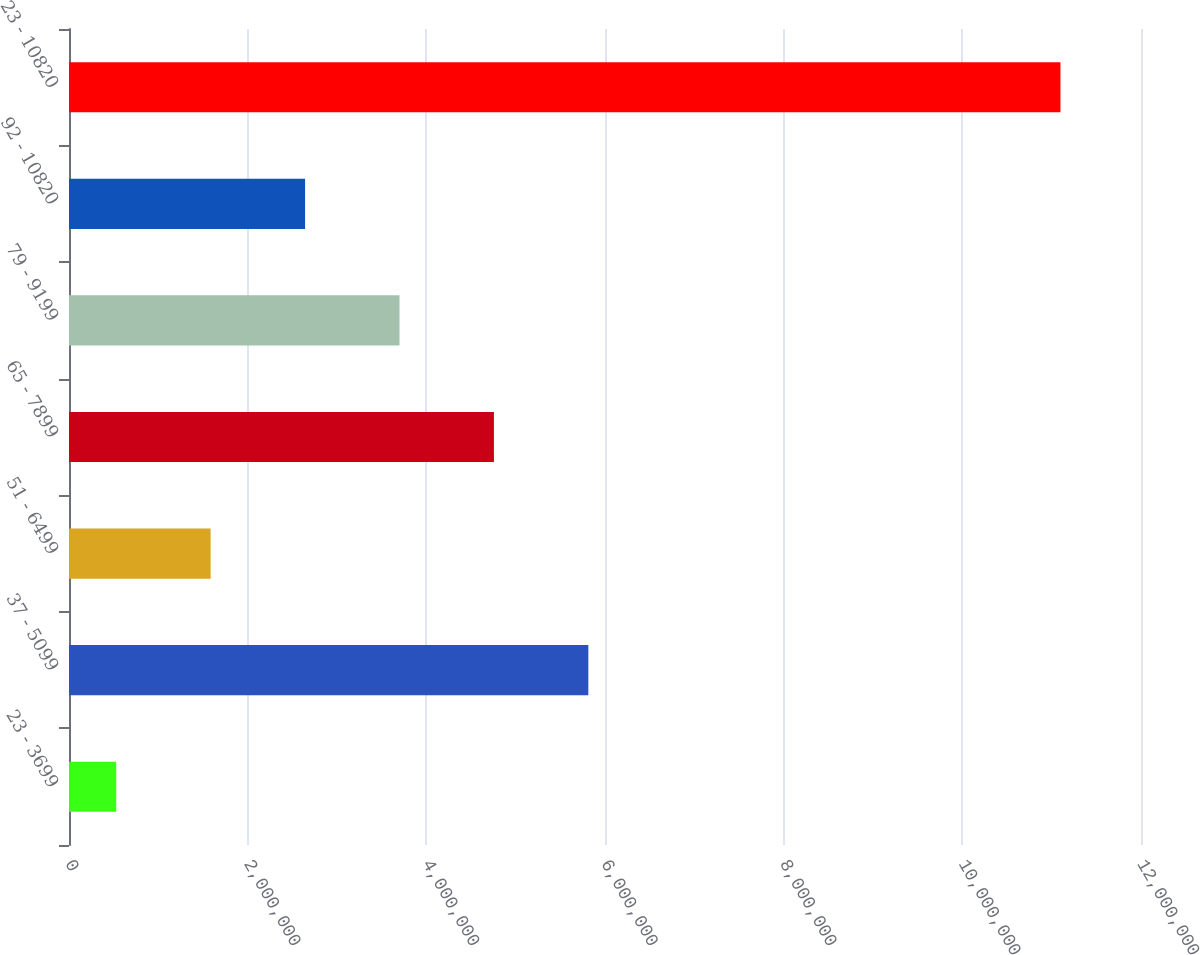Convert chart to OTSL. <chart><loc_0><loc_0><loc_500><loc_500><bar_chart><fcel>23 - 3699<fcel>37 - 5099<fcel>51 - 6499<fcel>65 - 7899<fcel>79 - 9199<fcel>92 - 10820<fcel>23 - 10820<nl><fcel>528683<fcel>5.81351e+06<fcel>1.58565e+06<fcel>4.75654e+06<fcel>3.69958e+06<fcel>2.64261e+06<fcel>1.10983e+07<nl></chart> 